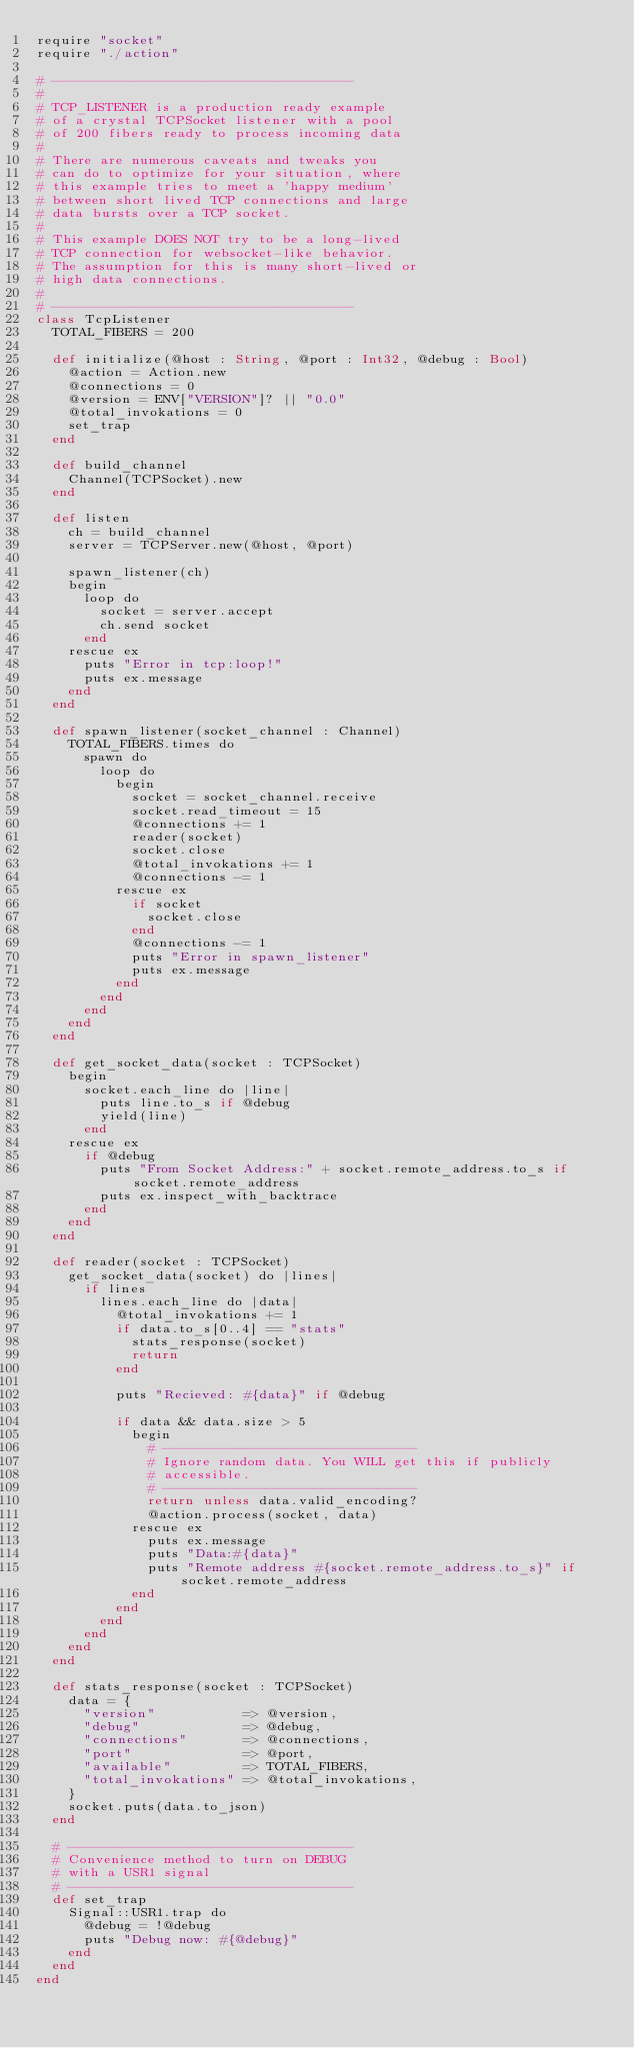Convert code to text. <code><loc_0><loc_0><loc_500><loc_500><_Crystal_>require "socket"
require "./action"

# --------------------------------------
#
# TCP_LISTENER is a production ready example
# of a crystal TCPSocket listener with a pool
# of 200 fibers ready to process incoming data
#
# There are numerous caveats and tweaks you
# can do to optimize for your situation, where
# this example tries to meet a 'happy medium'
# between short lived TCP connections and large
# data bursts over a TCP socket.
#
# This example DOES NOT try to be a long-lived
# TCP connection for websocket-like behavior.
# The assumption for this is many short-lived or
# high data connections.
#
# --------------------------------------
class TcpListener
  TOTAL_FIBERS = 200

  def initialize(@host : String, @port : Int32, @debug : Bool)
    @action = Action.new
    @connections = 0
    @version = ENV["VERSION"]? || "0.0"
    @total_invokations = 0
    set_trap
  end

  def build_channel
    Channel(TCPSocket).new
  end

  def listen
    ch = build_channel
    server = TCPServer.new(@host, @port)

    spawn_listener(ch)
    begin
      loop do
        socket = server.accept
        ch.send socket
      end
    rescue ex
      puts "Error in tcp:loop!"
      puts ex.message
    end
  end

  def spawn_listener(socket_channel : Channel)
    TOTAL_FIBERS.times do
      spawn do
        loop do
          begin
            socket = socket_channel.receive
            socket.read_timeout = 15
            @connections += 1
            reader(socket)
            socket.close
            @total_invokations += 1
            @connections -= 1
          rescue ex
            if socket
              socket.close
            end
            @connections -= 1
            puts "Error in spawn_listener"
            puts ex.message
          end
        end
      end
    end
  end

  def get_socket_data(socket : TCPSocket)
    begin
      socket.each_line do |line|
        puts line.to_s if @debug
        yield(line)
      end
    rescue ex
      if @debug
        puts "From Socket Address:" + socket.remote_address.to_s if socket.remote_address
        puts ex.inspect_with_backtrace
      end
    end
  end

  def reader(socket : TCPSocket)
    get_socket_data(socket) do |lines|
      if lines
        lines.each_line do |data|
          @total_invokations += 1
          if data.to_s[0..4] == "stats"
            stats_response(socket)
            return
          end

          puts "Recieved: #{data}" if @debug

          if data && data.size > 5
            begin
              # --------------------------------
              # Ignore random data. You WILL get this if publicly
              # accessible.
              # --------------------------------
              return unless data.valid_encoding?
              @action.process(socket, data)
            rescue ex
              puts ex.message
              puts "Data:#{data}"
              puts "Remote address #{socket.remote_address.to_s}" if socket.remote_address
            end
          end
        end
      end
    end
  end

  def stats_response(socket : TCPSocket)
    data = {
      "version"           => @version,
      "debug"             => @debug,
      "connections"       => @connections,
      "port"              => @port,
      "available"         => TOTAL_FIBERS,
      "total_invokations" => @total_invokations,
    }
    socket.puts(data.to_json)
  end

  # ------------------------------------
  # Convenience method to turn on DEBUG
  # with a USR1 signal
  # ------------------------------------
  def set_trap
    Signal::USR1.trap do
      @debug = !@debug
      puts "Debug now: #{@debug}"
    end
  end
end
</code> 